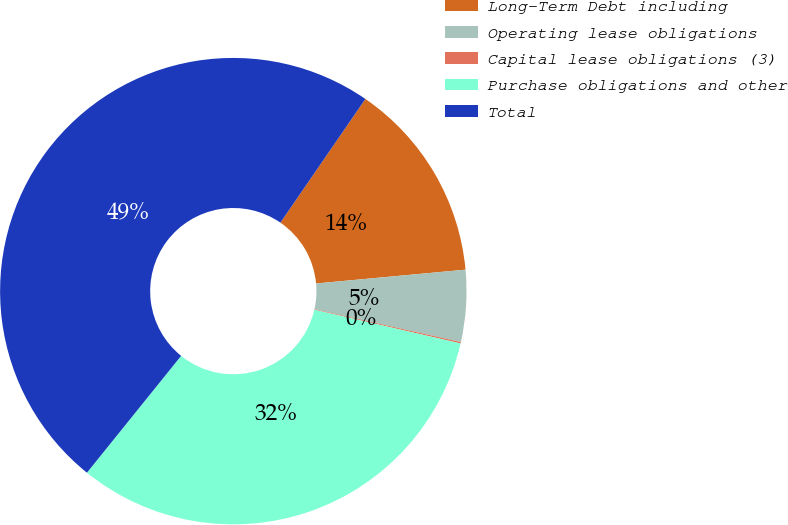Convert chart. <chart><loc_0><loc_0><loc_500><loc_500><pie_chart><fcel>Long-Term Debt including<fcel>Operating lease obligations<fcel>Capital lease obligations (3)<fcel>Purchase obligations and other<fcel>Total<nl><fcel>13.95%<fcel>4.97%<fcel>0.1%<fcel>32.2%<fcel>48.79%<nl></chart> 